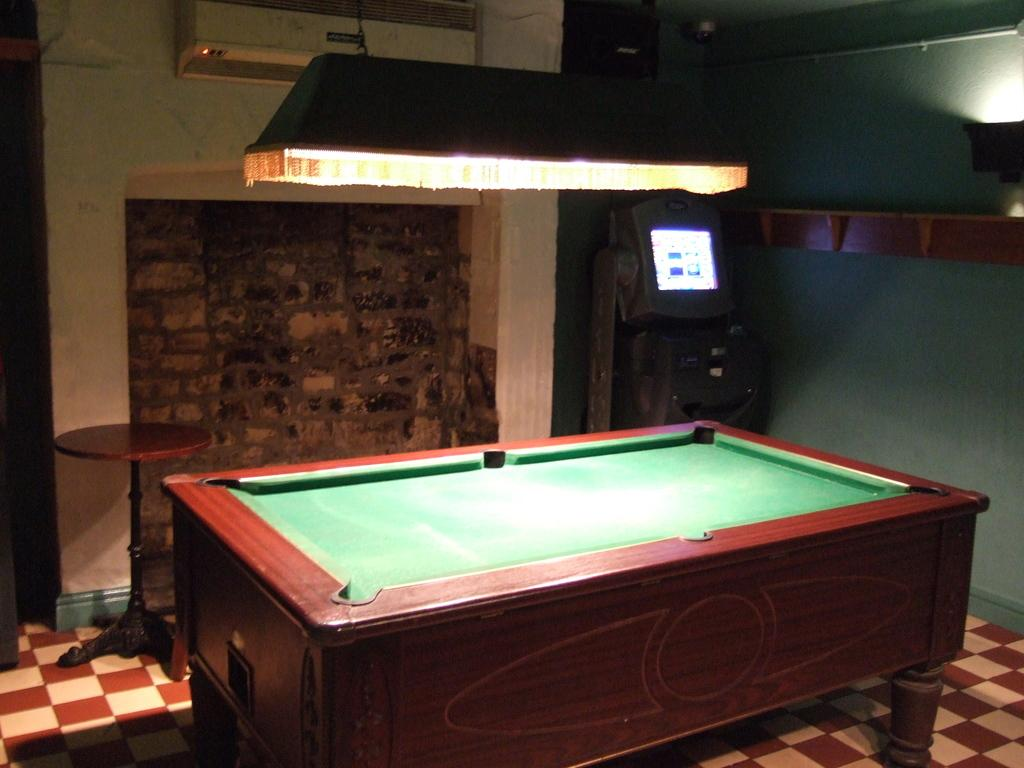What type of structure can be seen in the image? There is a wall in the image. What appliance is present in the image? There is an air conditioner in the image. What source of light is visible in the image? There is a light in the image. What type of screen is present in the image? There is a screen in the image. What type of game can be seen being played in the image? There is a billiards board in the image. What type of field is visible in the image? There is no field present in the image. What type of beam is holding up the ceiling in the image? There is no beam visible in the image, and the ceiling is not shown. 